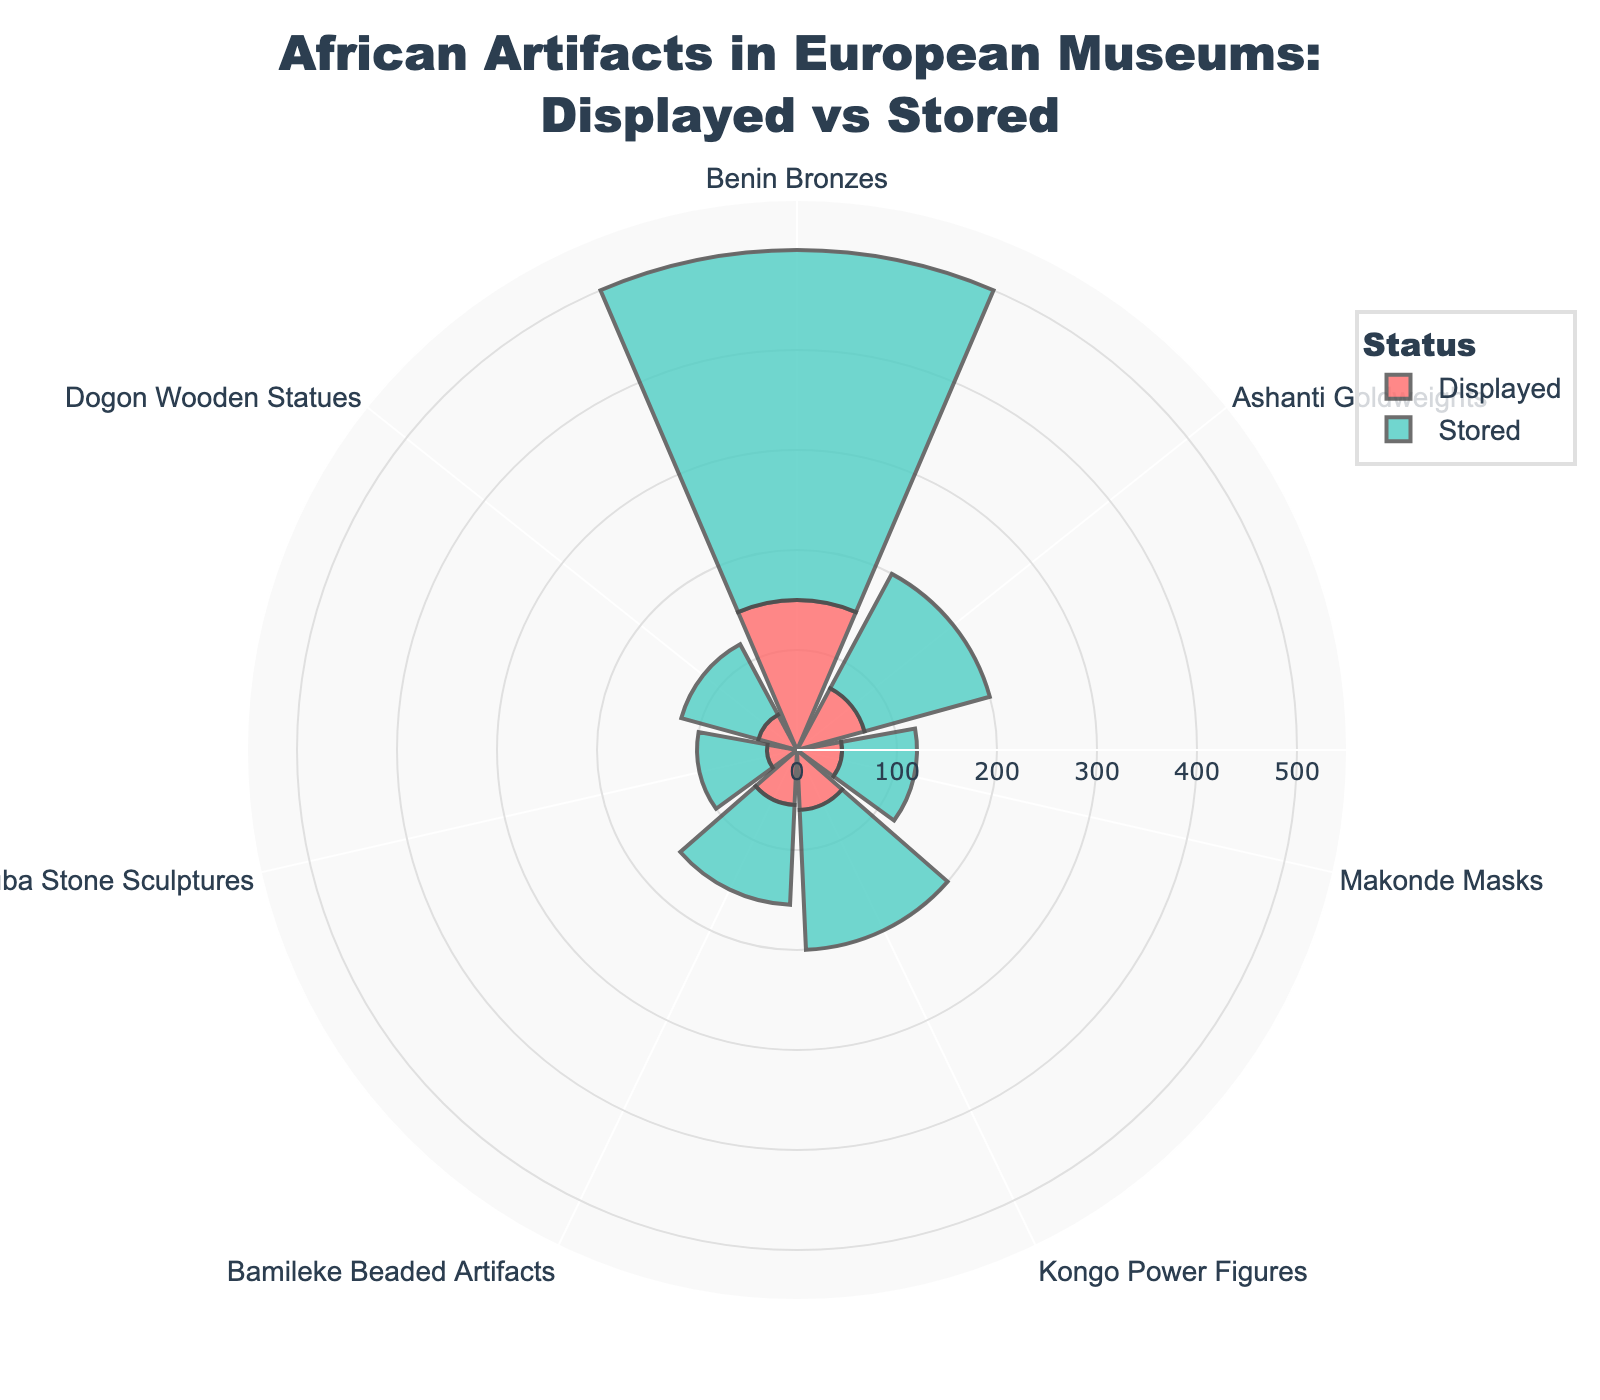What is the title of the chart? The title can be found at the top of the chart. It is usually written in a larger or bold font compared to other text on the chart.
Answer: African Artifacts in European Museums: Displayed vs Stored Which artifact type has the highest number of displayed items? Locate the bar with the maximum length in the segment labeled "Displayed" to identify this artifact type.
Answer: Benin Bronzes How many types of artifacts are displayed in the chart? Count the distinct labels around the polar chart to find out how many different artifact types are represented.
Answer: 7 What's the total number of Ashanti Goldweights in European museums? For this calculation, combine the number of displayed and stored Ashanti Goldweights by adding the two values.
Answer: 200 Which artifact type has more stored items compared to displayed ones, and by how much? Compare the lengths of each bar in the "Displayed" and "Stored" segments, then subtract the number of displayed items from stored items for each artifact type. Note those with a positive result.
Answer: Benin Bronzes, 200 Are there any artifact types with stored and displayed items in equal quantity? Compare the lengths of the bars within "Displayed" and "Stored" segments for equality. If lengths match, those artifact types have equal quantities.
Answer: No Which artifact type has the fewest displayed items? Identify the shortest bar in the segment labeled "Displayed."
Answer: Yoruba Stone Sculptures How many more Dogon Wooden Statues are stored than displayed in European museums? Subtract the number of displayed Dogon Wooden Statues from the stored Dogon Wooden Statues.
Answer: 40 What is the total number of all artifact types displayed in European museums? Sum the values of all the bars in the segment labeled "Displayed."
Answer: 450 Of the Kongo Power Figures, are there more displayed or stored in European museums? Compare the lengths of the Kongo Power Figures' bars in the "Displayed" and "Stored" segments.
Answer: Stored 